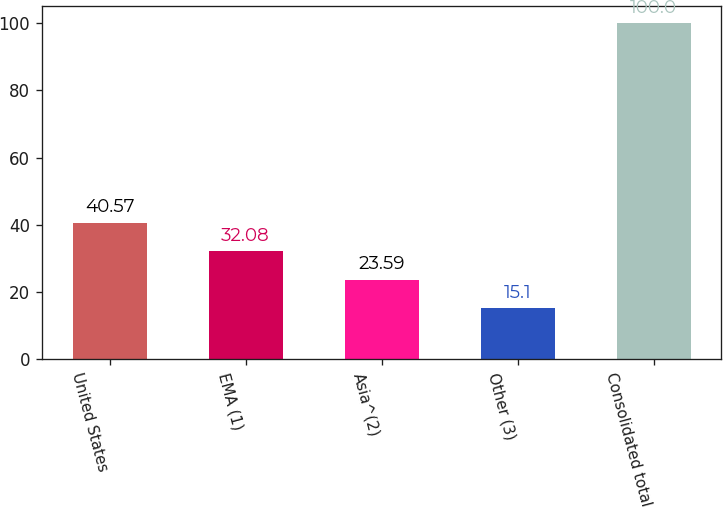Convert chart to OTSL. <chart><loc_0><loc_0><loc_500><loc_500><bar_chart><fcel>United States<fcel>EMA (1)<fcel>Asia^(2)<fcel>Other (3)<fcel>Consolidated total<nl><fcel>40.57<fcel>32.08<fcel>23.59<fcel>15.1<fcel>100<nl></chart> 